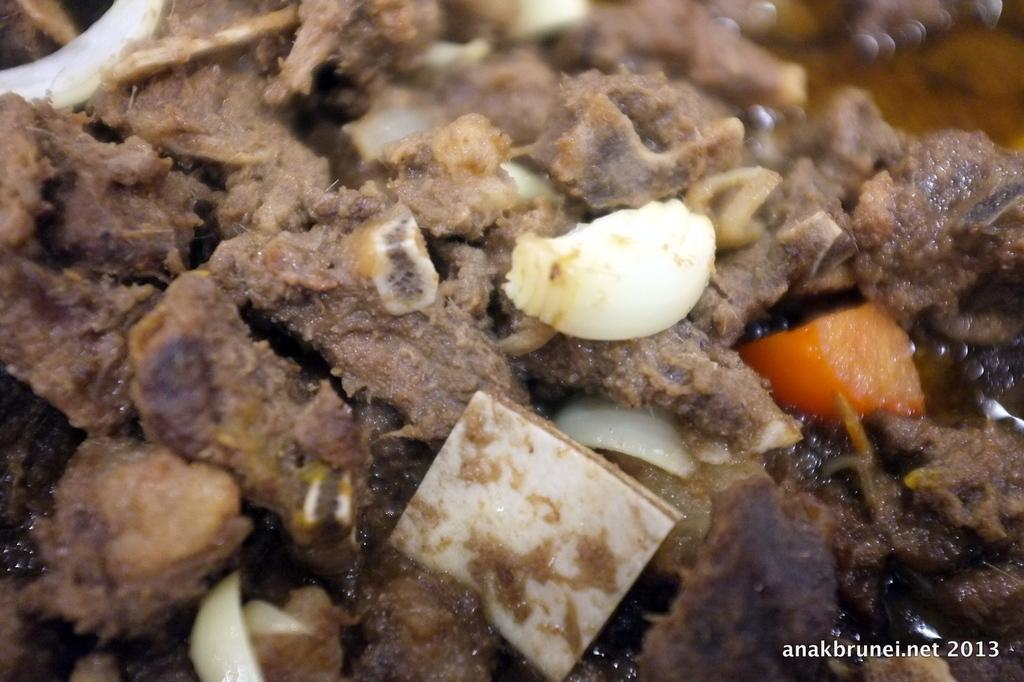What type of food can be seen in the image? The image contains food, but the specific type cannot be determined from the provided facts. What colors are present in the food? The food has brown, white, and orange colors. What type of fish can be seen swimming in the paint in the image? There is no fish or paint present in the image; it only contains food with brown, white, and orange colors. 